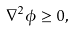<formula> <loc_0><loc_0><loc_500><loc_500>\nabla ^ { 2 } \phi \geq 0 ,</formula> 